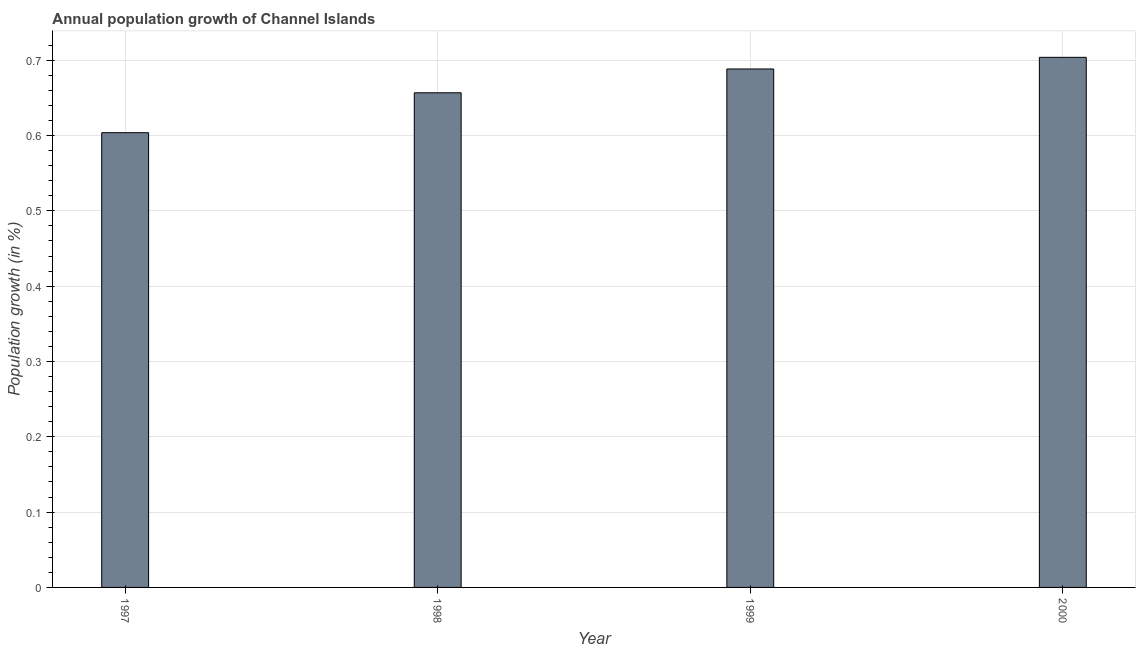Does the graph contain grids?
Your answer should be very brief. Yes. What is the title of the graph?
Give a very brief answer. Annual population growth of Channel Islands. What is the label or title of the X-axis?
Make the answer very short. Year. What is the label or title of the Y-axis?
Offer a very short reply. Population growth (in %). What is the population growth in 1997?
Ensure brevity in your answer.  0.6. Across all years, what is the maximum population growth?
Make the answer very short. 0.7. Across all years, what is the minimum population growth?
Make the answer very short. 0.6. In which year was the population growth maximum?
Your answer should be very brief. 2000. What is the sum of the population growth?
Offer a very short reply. 2.65. What is the difference between the population growth in 1999 and 2000?
Make the answer very short. -0.01. What is the average population growth per year?
Offer a terse response. 0.66. What is the median population growth?
Your answer should be compact. 0.67. Do a majority of the years between 1999 and 1998 (inclusive) have population growth greater than 0.34 %?
Your answer should be compact. No. What is the ratio of the population growth in 1998 to that in 2000?
Keep it short and to the point. 0.93. What is the difference between the highest and the second highest population growth?
Give a very brief answer. 0.01. Is the sum of the population growth in 1997 and 1998 greater than the maximum population growth across all years?
Your answer should be compact. Yes. What is the difference between two consecutive major ticks on the Y-axis?
Ensure brevity in your answer.  0.1. Are the values on the major ticks of Y-axis written in scientific E-notation?
Give a very brief answer. No. What is the Population growth (in %) of 1997?
Provide a succinct answer. 0.6. What is the Population growth (in %) of 1998?
Your answer should be compact. 0.66. What is the Population growth (in %) in 1999?
Provide a short and direct response. 0.69. What is the Population growth (in %) in 2000?
Make the answer very short. 0.7. What is the difference between the Population growth (in %) in 1997 and 1998?
Your answer should be compact. -0.05. What is the difference between the Population growth (in %) in 1997 and 1999?
Provide a short and direct response. -0.08. What is the difference between the Population growth (in %) in 1997 and 2000?
Ensure brevity in your answer.  -0.1. What is the difference between the Population growth (in %) in 1998 and 1999?
Your response must be concise. -0.03. What is the difference between the Population growth (in %) in 1998 and 2000?
Your response must be concise. -0.05. What is the difference between the Population growth (in %) in 1999 and 2000?
Provide a short and direct response. -0.02. What is the ratio of the Population growth (in %) in 1997 to that in 1998?
Offer a terse response. 0.92. What is the ratio of the Population growth (in %) in 1997 to that in 1999?
Provide a short and direct response. 0.88. What is the ratio of the Population growth (in %) in 1997 to that in 2000?
Give a very brief answer. 0.86. What is the ratio of the Population growth (in %) in 1998 to that in 1999?
Your response must be concise. 0.95. What is the ratio of the Population growth (in %) in 1998 to that in 2000?
Your answer should be very brief. 0.93. What is the ratio of the Population growth (in %) in 1999 to that in 2000?
Offer a very short reply. 0.98. 